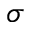<formula> <loc_0><loc_0><loc_500><loc_500>\sigma</formula> 